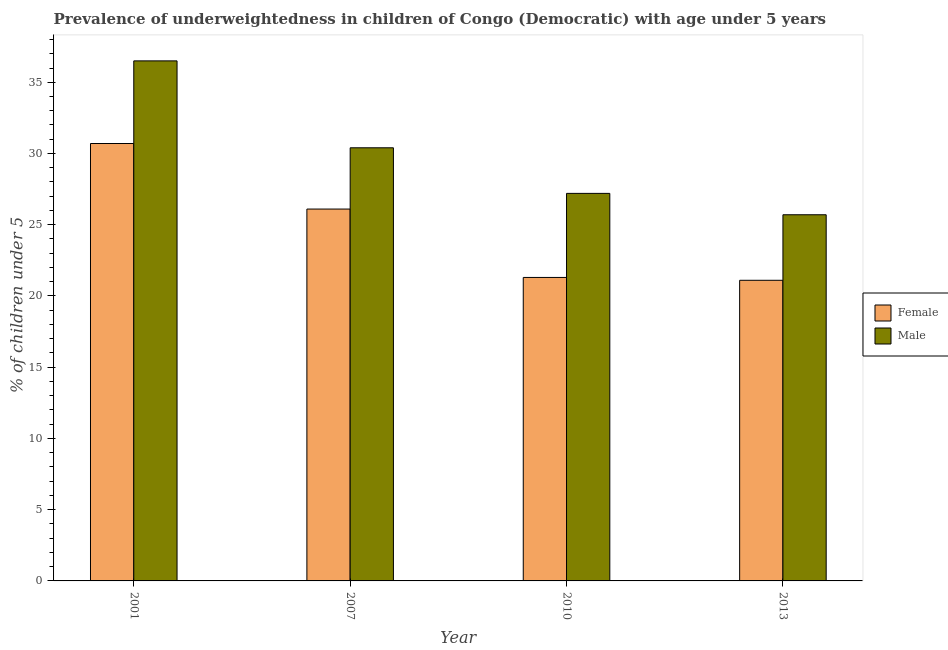How many different coloured bars are there?
Make the answer very short. 2. How many groups of bars are there?
Offer a very short reply. 4. How many bars are there on the 2nd tick from the left?
Offer a terse response. 2. How many bars are there on the 4th tick from the right?
Give a very brief answer. 2. In how many cases, is the number of bars for a given year not equal to the number of legend labels?
Keep it short and to the point. 0. What is the percentage of underweighted male children in 2010?
Offer a very short reply. 27.2. Across all years, what is the maximum percentage of underweighted female children?
Make the answer very short. 30.7. Across all years, what is the minimum percentage of underweighted male children?
Provide a short and direct response. 25.7. In which year was the percentage of underweighted male children maximum?
Ensure brevity in your answer.  2001. In which year was the percentage of underweighted male children minimum?
Offer a terse response. 2013. What is the total percentage of underweighted female children in the graph?
Keep it short and to the point. 99.2. What is the difference between the percentage of underweighted female children in 2001 and that in 2010?
Give a very brief answer. 9.4. What is the difference between the percentage of underweighted male children in 2013 and the percentage of underweighted female children in 2010?
Keep it short and to the point. -1.5. What is the average percentage of underweighted female children per year?
Your answer should be compact. 24.8. What is the ratio of the percentage of underweighted male children in 2010 to that in 2013?
Your answer should be compact. 1.06. Is the percentage of underweighted male children in 2001 less than that in 2013?
Your answer should be compact. No. What is the difference between the highest and the second highest percentage of underweighted male children?
Provide a short and direct response. 6.1. What is the difference between the highest and the lowest percentage of underweighted male children?
Offer a very short reply. 10.8. Is the sum of the percentage of underweighted female children in 2007 and 2013 greater than the maximum percentage of underweighted male children across all years?
Your answer should be compact. Yes. What does the 1st bar from the left in 2010 represents?
Your response must be concise. Female. What does the 2nd bar from the right in 2010 represents?
Offer a very short reply. Female. How many bars are there?
Your answer should be very brief. 8. How many years are there in the graph?
Your answer should be compact. 4. Does the graph contain any zero values?
Your answer should be compact. No. Does the graph contain grids?
Keep it short and to the point. No. Where does the legend appear in the graph?
Your answer should be very brief. Center right. How many legend labels are there?
Make the answer very short. 2. What is the title of the graph?
Offer a very short reply. Prevalence of underweightedness in children of Congo (Democratic) with age under 5 years. What is the label or title of the Y-axis?
Make the answer very short.  % of children under 5. What is the  % of children under 5 in Female in 2001?
Make the answer very short. 30.7. What is the  % of children under 5 of Male in 2001?
Provide a short and direct response. 36.5. What is the  % of children under 5 in Female in 2007?
Your response must be concise. 26.1. What is the  % of children under 5 in Male in 2007?
Give a very brief answer. 30.4. What is the  % of children under 5 of Female in 2010?
Offer a very short reply. 21.3. What is the  % of children under 5 of Male in 2010?
Your answer should be compact. 27.2. What is the  % of children under 5 in Female in 2013?
Make the answer very short. 21.1. What is the  % of children under 5 in Male in 2013?
Ensure brevity in your answer.  25.7. Across all years, what is the maximum  % of children under 5 in Female?
Offer a very short reply. 30.7. Across all years, what is the maximum  % of children under 5 in Male?
Offer a terse response. 36.5. Across all years, what is the minimum  % of children under 5 of Female?
Ensure brevity in your answer.  21.1. Across all years, what is the minimum  % of children under 5 in Male?
Your response must be concise. 25.7. What is the total  % of children under 5 of Female in the graph?
Your answer should be compact. 99.2. What is the total  % of children under 5 in Male in the graph?
Your response must be concise. 119.8. What is the difference between the  % of children under 5 in Male in 2001 and that in 2007?
Ensure brevity in your answer.  6.1. What is the difference between the  % of children under 5 in Male in 2001 and that in 2010?
Make the answer very short. 9.3. What is the difference between the  % of children under 5 in Male in 2001 and that in 2013?
Offer a very short reply. 10.8. What is the difference between the  % of children under 5 of Male in 2007 and that in 2010?
Your answer should be compact. 3.2. What is the difference between the  % of children under 5 in Male in 2007 and that in 2013?
Keep it short and to the point. 4.7. What is the difference between the  % of children under 5 in Female in 2010 and that in 2013?
Offer a terse response. 0.2. What is the difference between the  % of children under 5 of Male in 2010 and that in 2013?
Give a very brief answer. 1.5. What is the difference between the  % of children under 5 of Female in 2001 and the  % of children under 5 of Male in 2007?
Ensure brevity in your answer.  0.3. What is the difference between the  % of children under 5 of Female in 2001 and the  % of children under 5 of Male in 2010?
Offer a terse response. 3.5. What is the difference between the  % of children under 5 of Female in 2001 and the  % of children under 5 of Male in 2013?
Provide a short and direct response. 5. What is the difference between the  % of children under 5 of Female in 2007 and the  % of children under 5 of Male in 2010?
Your response must be concise. -1.1. What is the average  % of children under 5 of Female per year?
Provide a short and direct response. 24.8. What is the average  % of children under 5 of Male per year?
Ensure brevity in your answer.  29.95. In the year 2001, what is the difference between the  % of children under 5 of Female and  % of children under 5 of Male?
Your answer should be compact. -5.8. In the year 2007, what is the difference between the  % of children under 5 in Female and  % of children under 5 in Male?
Offer a terse response. -4.3. In the year 2010, what is the difference between the  % of children under 5 in Female and  % of children under 5 in Male?
Provide a short and direct response. -5.9. What is the ratio of the  % of children under 5 of Female in 2001 to that in 2007?
Offer a terse response. 1.18. What is the ratio of the  % of children under 5 of Male in 2001 to that in 2007?
Provide a succinct answer. 1.2. What is the ratio of the  % of children under 5 in Female in 2001 to that in 2010?
Provide a short and direct response. 1.44. What is the ratio of the  % of children under 5 in Male in 2001 to that in 2010?
Provide a short and direct response. 1.34. What is the ratio of the  % of children under 5 of Female in 2001 to that in 2013?
Make the answer very short. 1.46. What is the ratio of the  % of children under 5 in Male in 2001 to that in 2013?
Provide a succinct answer. 1.42. What is the ratio of the  % of children under 5 in Female in 2007 to that in 2010?
Give a very brief answer. 1.23. What is the ratio of the  % of children under 5 of Male in 2007 to that in 2010?
Provide a succinct answer. 1.12. What is the ratio of the  % of children under 5 in Female in 2007 to that in 2013?
Provide a succinct answer. 1.24. What is the ratio of the  % of children under 5 of Male in 2007 to that in 2013?
Your answer should be compact. 1.18. What is the ratio of the  % of children under 5 in Female in 2010 to that in 2013?
Provide a short and direct response. 1.01. What is the ratio of the  % of children under 5 of Male in 2010 to that in 2013?
Your response must be concise. 1.06. What is the difference between the highest and the second highest  % of children under 5 of Female?
Keep it short and to the point. 4.6. What is the difference between the highest and the second highest  % of children under 5 in Male?
Keep it short and to the point. 6.1. What is the difference between the highest and the lowest  % of children under 5 in Male?
Your answer should be very brief. 10.8. 